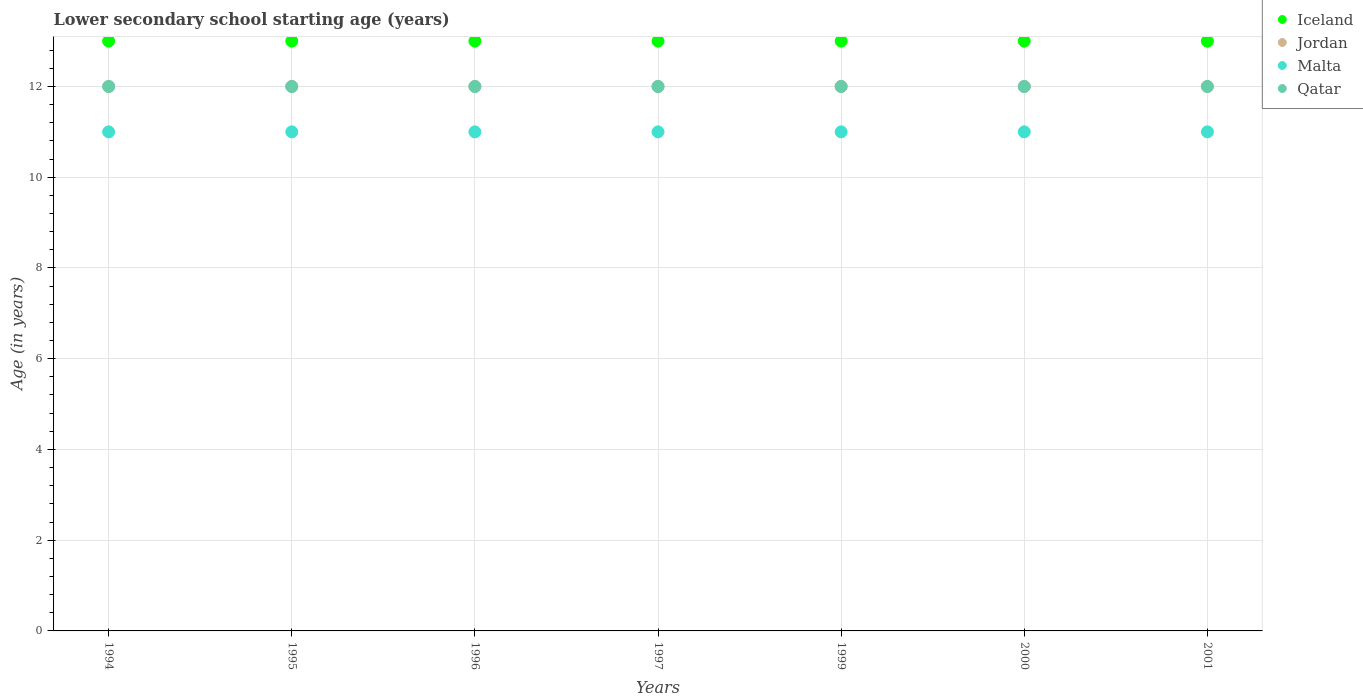How many different coloured dotlines are there?
Offer a very short reply. 4. Across all years, what is the minimum lower secondary school starting age of children in Malta?
Keep it short and to the point. 11. In which year was the lower secondary school starting age of children in Iceland maximum?
Ensure brevity in your answer.  1994. What is the total lower secondary school starting age of children in Iceland in the graph?
Make the answer very short. 91. What is the difference between the lower secondary school starting age of children in Malta in 1994 and that in 1997?
Ensure brevity in your answer.  0. What is the difference between the lower secondary school starting age of children in Malta in 2001 and the lower secondary school starting age of children in Iceland in 1996?
Offer a very short reply. -2. What is the average lower secondary school starting age of children in Malta per year?
Offer a terse response. 11. What is the ratio of the lower secondary school starting age of children in Iceland in 1994 to that in 1995?
Ensure brevity in your answer.  1. Is the difference between the lower secondary school starting age of children in Iceland in 1995 and 2001 greater than the difference between the lower secondary school starting age of children in Jordan in 1995 and 2001?
Keep it short and to the point. No. In how many years, is the lower secondary school starting age of children in Jordan greater than the average lower secondary school starting age of children in Jordan taken over all years?
Provide a short and direct response. 0. Is it the case that in every year, the sum of the lower secondary school starting age of children in Malta and lower secondary school starting age of children in Jordan  is greater than the sum of lower secondary school starting age of children in Iceland and lower secondary school starting age of children in Qatar?
Ensure brevity in your answer.  No. Does the lower secondary school starting age of children in Iceland monotonically increase over the years?
Offer a terse response. No. How many years are there in the graph?
Your response must be concise. 7. What is the difference between two consecutive major ticks on the Y-axis?
Provide a short and direct response. 2. Does the graph contain any zero values?
Keep it short and to the point. No. Does the graph contain grids?
Ensure brevity in your answer.  Yes. Where does the legend appear in the graph?
Your response must be concise. Top right. How many legend labels are there?
Ensure brevity in your answer.  4. How are the legend labels stacked?
Offer a terse response. Vertical. What is the title of the graph?
Your answer should be very brief. Lower secondary school starting age (years). What is the label or title of the X-axis?
Provide a succinct answer. Years. What is the label or title of the Y-axis?
Your response must be concise. Age (in years). What is the Age (in years) of Iceland in 1994?
Your answer should be compact. 13. What is the Age (in years) of Jordan in 1994?
Offer a very short reply. 12. What is the Age (in years) of Malta in 1994?
Give a very brief answer. 11. What is the Age (in years) in Qatar in 1994?
Provide a succinct answer. 12. What is the Age (in years) of Malta in 1995?
Make the answer very short. 11. What is the Age (in years) of Qatar in 1995?
Provide a succinct answer. 12. What is the Age (in years) of Iceland in 1996?
Offer a very short reply. 13. What is the Age (in years) of Malta in 1996?
Give a very brief answer. 11. What is the Age (in years) of Qatar in 1996?
Give a very brief answer. 12. What is the Age (in years) in Jordan in 1997?
Provide a succinct answer. 12. What is the Age (in years) of Malta in 1999?
Give a very brief answer. 11. What is the Age (in years) of Qatar in 1999?
Give a very brief answer. 12. What is the Age (in years) of Jordan in 2000?
Keep it short and to the point. 12. What is the Age (in years) of Malta in 2000?
Make the answer very short. 11. What is the Age (in years) in Qatar in 2000?
Offer a terse response. 12. What is the Age (in years) in Iceland in 2001?
Your answer should be compact. 13. What is the Age (in years) of Jordan in 2001?
Your response must be concise. 12. What is the Age (in years) in Malta in 2001?
Provide a short and direct response. 11. What is the Age (in years) in Qatar in 2001?
Offer a very short reply. 12. Across all years, what is the maximum Age (in years) in Jordan?
Offer a terse response. 12. Across all years, what is the maximum Age (in years) of Qatar?
Provide a succinct answer. 12. Across all years, what is the minimum Age (in years) in Iceland?
Offer a very short reply. 13. Across all years, what is the minimum Age (in years) in Malta?
Offer a very short reply. 11. What is the total Age (in years) of Iceland in the graph?
Keep it short and to the point. 91. What is the total Age (in years) of Jordan in the graph?
Provide a short and direct response. 84. What is the difference between the Age (in years) in Jordan in 1994 and that in 1995?
Give a very brief answer. 0. What is the difference between the Age (in years) in Malta in 1994 and that in 1995?
Give a very brief answer. 0. What is the difference between the Age (in years) of Jordan in 1994 and that in 1996?
Your answer should be compact. 0. What is the difference between the Age (in years) of Iceland in 1994 and that in 1997?
Offer a terse response. 0. What is the difference between the Age (in years) of Jordan in 1994 and that in 1997?
Give a very brief answer. 0. What is the difference between the Age (in years) in Malta in 1994 and that in 1997?
Make the answer very short. 0. What is the difference between the Age (in years) of Qatar in 1994 and that in 1997?
Keep it short and to the point. 0. What is the difference between the Age (in years) of Jordan in 1994 and that in 1999?
Ensure brevity in your answer.  0. What is the difference between the Age (in years) of Malta in 1994 and that in 1999?
Your answer should be compact. 0. What is the difference between the Age (in years) of Qatar in 1994 and that in 1999?
Give a very brief answer. 0. What is the difference between the Age (in years) of Iceland in 1994 and that in 2000?
Ensure brevity in your answer.  0. What is the difference between the Age (in years) in Jordan in 1994 and that in 2000?
Offer a very short reply. 0. What is the difference between the Age (in years) of Malta in 1994 and that in 2000?
Your answer should be compact. 0. What is the difference between the Age (in years) in Jordan in 1994 and that in 2001?
Keep it short and to the point. 0. What is the difference between the Age (in years) in Malta in 1994 and that in 2001?
Provide a succinct answer. 0. What is the difference between the Age (in years) of Iceland in 1995 and that in 1996?
Provide a succinct answer. 0. What is the difference between the Age (in years) in Malta in 1995 and that in 1996?
Ensure brevity in your answer.  0. What is the difference between the Age (in years) of Qatar in 1995 and that in 1997?
Provide a short and direct response. 0. What is the difference between the Age (in years) of Iceland in 1995 and that in 1999?
Ensure brevity in your answer.  0. What is the difference between the Age (in years) in Jordan in 1995 and that in 1999?
Ensure brevity in your answer.  0. What is the difference between the Age (in years) in Qatar in 1995 and that in 1999?
Your answer should be very brief. 0. What is the difference between the Age (in years) in Jordan in 1995 and that in 2001?
Offer a terse response. 0. What is the difference between the Age (in years) in Qatar in 1995 and that in 2001?
Provide a succinct answer. 0. What is the difference between the Age (in years) in Iceland in 1996 and that in 1997?
Your answer should be compact. 0. What is the difference between the Age (in years) of Qatar in 1996 and that in 1997?
Keep it short and to the point. 0. What is the difference between the Age (in years) of Iceland in 1996 and that in 1999?
Your answer should be very brief. 0. What is the difference between the Age (in years) of Jordan in 1996 and that in 1999?
Ensure brevity in your answer.  0. What is the difference between the Age (in years) of Malta in 1996 and that in 1999?
Offer a very short reply. 0. What is the difference between the Age (in years) of Iceland in 1996 and that in 2001?
Make the answer very short. 0. What is the difference between the Age (in years) in Jordan in 1997 and that in 1999?
Provide a short and direct response. 0. What is the difference between the Age (in years) of Jordan in 1997 and that in 2000?
Keep it short and to the point. 0. What is the difference between the Age (in years) of Malta in 1997 and that in 2000?
Offer a terse response. 0. What is the difference between the Age (in years) in Iceland in 1997 and that in 2001?
Provide a succinct answer. 0. What is the difference between the Age (in years) of Malta in 1999 and that in 2000?
Provide a succinct answer. 0. What is the difference between the Age (in years) of Qatar in 1999 and that in 2000?
Provide a succinct answer. 0. What is the difference between the Age (in years) of Iceland in 1999 and that in 2001?
Offer a terse response. 0. What is the difference between the Age (in years) of Qatar in 2000 and that in 2001?
Make the answer very short. 0. What is the difference between the Age (in years) of Iceland in 1994 and the Age (in years) of Jordan in 1995?
Provide a short and direct response. 1. What is the difference between the Age (in years) of Iceland in 1994 and the Age (in years) of Jordan in 1996?
Your answer should be very brief. 1. What is the difference between the Age (in years) of Iceland in 1994 and the Age (in years) of Qatar in 1996?
Ensure brevity in your answer.  1. What is the difference between the Age (in years) in Jordan in 1994 and the Age (in years) in Malta in 1996?
Provide a succinct answer. 1. What is the difference between the Age (in years) in Jordan in 1994 and the Age (in years) in Qatar in 1996?
Give a very brief answer. 0. What is the difference between the Age (in years) of Malta in 1994 and the Age (in years) of Qatar in 1996?
Ensure brevity in your answer.  -1. What is the difference between the Age (in years) in Iceland in 1994 and the Age (in years) in Jordan in 1997?
Your answer should be very brief. 1. What is the difference between the Age (in years) in Iceland in 1994 and the Age (in years) in Malta in 1997?
Give a very brief answer. 2. What is the difference between the Age (in years) of Jordan in 1994 and the Age (in years) of Malta in 1997?
Your response must be concise. 1. What is the difference between the Age (in years) in Malta in 1994 and the Age (in years) in Qatar in 1997?
Ensure brevity in your answer.  -1. What is the difference between the Age (in years) of Iceland in 1994 and the Age (in years) of Jordan in 1999?
Offer a terse response. 1. What is the difference between the Age (in years) in Iceland in 1994 and the Age (in years) in Malta in 1999?
Your response must be concise. 2. What is the difference between the Age (in years) in Iceland in 1994 and the Age (in years) in Qatar in 1999?
Provide a succinct answer. 1. What is the difference between the Age (in years) in Jordan in 1994 and the Age (in years) in Malta in 1999?
Make the answer very short. 1. What is the difference between the Age (in years) in Malta in 1994 and the Age (in years) in Qatar in 1999?
Make the answer very short. -1. What is the difference between the Age (in years) of Iceland in 1994 and the Age (in years) of Jordan in 2000?
Your response must be concise. 1. What is the difference between the Age (in years) in Iceland in 1994 and the Age (in years) in Malta in 2000?
Provide a succinct answer. 2. What is the difference between the Age (in years) in Iceland in 1994 and the Age (in years) in Qatar in 2000?
Keep it short and to the point. 1. What is the difference between the Age (in years) in Iceland in 1994 and the Age (in years) in Malta in 2001?
Offer a terse response. 2. What is the difference between the Age (in years) in Iceland in 1995 and the Age (in years) in Jordan in 1996?
Provide a succinct answer. 1. What is the difference between the Age (in years) of Iceland in 1995 and the Age (in years) of Malta in 1996?
Give a very brief answer. 2. What is the difference between the Age (in years) in Malta in 1995 and the Age (in years) in Qatar in 1996?
Your answer should be compact. -1. What is the difference between the Age (in years) in Iceland in 1995 and the Age (in years) in Malta in 1997?
Offer a very short reply. 2. What is the difference between the Age (in years) in Jordan in 1995 and the Age (in years) in Malta in 1997?
Your answer should be very brief. 1. What is the difference between the Age (in years) of Malta in 1995 and the Age (in years) of Qatar in 1997?
Offer a very short reply. -1. What is the difference between the Age (in years) in Iceland in 1995 and the Age (in years) in Jordan in 1999?
Your response must be concise. 1. What is the difference between the Age (in years) in Iceland in 1995 and the Age (in years) in Malta in 1999?
Offer a terse response. 2. What is the difference between the Age (in years) of Malta in 1995 and the Age (in years) of Qatar in 1999?
Your answer should be very brief. -1. What is the difference between the Age (in years) in Iceland in 1995 and the Age (in years) in Jordan in 2000?
Make the answer very short. 1. What is the difference between the Age (in years) in Iceland in 1995 and the Age (in years) in Malta in 2000?
Ensure brevity in your answer.  2. What is the difference between the Age (in years) of Iceland in 1995 and the Age (in years) of Qatar in 2000?
Make the answer very short. 1. What is the difference between the Age (in years) of Jordan in 1995 and the Age (in years) of Qatar in 2000?
Ensure brevity in your answer.  0. What is the difference between the Age (in years) of Malta in 1995 and the Age (in years) of Qatar in 2000?
Keep it short and to the point. -1. What is the difference between the Age (in years) in Iceland in 1995 and the Age (in years) in Jordan in 2001?
Your answer should be compact. 1. What is the difference between the Age (in years) in Jordan in 1995 and the Age (in years) in Malta in 2001?
Make the answer very short. 1. What is the difference between the Age (in years) in Jordan in 1995 and the Age (in years) in Qatar in 2001?
Keep it short and to the point. 0. What is the difference between the Age (in years) in Iceland in 1996 and the Age (in years) in Jordan in 1997?
Your answer should be very brief. 1. What is the difference between the Age (in years) in Iceland in 1996 and the Age (in years) in Malta in 1997?
Offer a very short reply. 2. What is the difference between the Age (in years) in Iceland in 1996 and the Age (in years) in Qatar in 1997?
Give a very brief answer. 1. What is the difference between the Age (in years) in Jordan in 1996 and the Age (in years) in Qatar in 1997?
Your response must be concise. 0. What is the difference between the Age (in years) of Iceland in 1996 and the Age (in years) of Jordan in 1999?
Your answer should be compact. 1. What is the difference between the Age (in years) in Iceland in 1996 and the Age (in years) in Malta in 1999?
Provide a succinct answer. 2. What is the difference between the Age (in years) in Jordan in 1996 and the Age (in years) in Qatar in 1999?
Keep it short and to the point. 0. What is the difference between the Age (in years) in Iceland in 1996 and the Age (in years) in Malta in 2000?
Make the answer very short. 2. What is the difference between the Age (in years) of Iceland in 1996 and the Age (in years) of Jordan in 2001?
Provide a short and direct response. 1. What is the difference between the Age (in years) in Iceland in 1996 and the Age (in years) in Qatar in 2001?
Give a very brief answer. 1. What is the difference between the Age (in years) of Jordan in 1996 and the Age (in years) of Malta in 2001?
Make the answer very short. 1. What is the difference between the Age (in years) in Jordan in 1996 and the Age (in years) in Qatar in 2001?
Make the answer very short. 0. What is the difference between the Age (in years) in Iceland in 1997 and the Age (in years) in Jordan in 1999?
Offer a very short reply. 1. What is the difference between the Age (in years) in Iceland in 1997 and the Age (in years) in Malta in 1999?
Keep it short and to the point. 2. What is the difference between the Age (in years) of Iceland in 1997 and the Age (in years) of Qatar in 1999?
Ensure brevity in your answer.  1. What is the difference between the Age (in years) in Jordan in 1997 and the Age (in years) in Qatar in 1999?
Provide a short and direct response. 0. What is the difference between the Age (in years) of Jordan in 1997 and the Age (in years) of Qatar in 2000?
Provide a short and direct response. 0. What is the difference between the Age (in years) of Iceland in 1997 and the Age (in years) of Jordan in 2001?
Provide a succinct answer. 1. What is the difference between the Age (in years) of Iceland in 1997 and the Age (in years) of Qatar in 2001?
Offer a terse response. 1. What is the difference between the Age (in years) of Jordan in 1997 and the Age (in years) of Malta in 2001?
Your answer should be very brief. 1. What is the difference between the Age (in years) in Malta in 1997 and the Age (in years) in Qatar in 2001?
Your answer should be very brief. -1. What is the difference between the Age (in years) of Iceland in 1999 and the Age (in years) of Malta in 2000?
Your response must be concise. 2. What is the difference between the Age (in years) of Iceland in 1999 and the Age (in years) of Qatar in 2000?
Keep it short and to the point. 1. What is the difference between the Age (in years) in Jordan in 1999 and the Age (in years) in Malta in 2000?
Ensure brevity in your answer.  1. What is the difference between the Age (in years) of Malta in 1999 and the Age (in years) of Qatar in 2000?
Provide a succinct answer. -1. What is the difference between the Age (in years) in Iceland in 1999 and the Age (in years) in Jordan in 2001?
Ensure brevity in your answer.  1. What is the difference between the Age (in years) in Iceland in 1999 and the Age (in years) in Qatar in 2001?
Make the answer very short. 1. What is the difference between the Age (in years) of Jordan in 1999 and the Age (in years) of Qatar in 2001?
Your answer should be compact. 0. What is the difference between the Age (in years) in Malta in 1999 and the Age (in years) in Qatar in 2001?
Ensure brevity in your answer.  -1. What is the difference between the Age (in years) in Iceland in 2000 and the Age (in years) in Jordan in 2001?
Offer a very short reply. 1. What is the difference between the Age (in years) of Iceland in 2000 and the Age (in years) of Malta in 2001?
Give a very brief answer. 2. What is the difference between the Age (in years) in Iceland in 2000 and the Age (in years) in Qatar in 2001?
Provide a succinct answer. 1. What is the difference between the Age (in years) in Jordan in 2000 and the Age (in years) in Malta in 2001?
Your response must be concise. 1. What is the difference between the Age (in years) of Jordan in 2000 and the Age (in years) of Qatar in 2001?
Give a very brief answer. 0. What is the difference between the Age (in years) of Malta in 2000 and the Age (in years) of Qatar in 2001?
Provide a succinct answer. -1. What is the average Age (in years) of Iceland per year?
Your answer should be compact. 13. What is the average Age (in years) of Malta per year?
Provide a short and direct response. 11. In the year 1994, what is the difference between the Age (in years) in Iceland and Age (in years) in Jordan?
Provide a short and direct response. 1. In the year 1994, what is the difference between the Age (in years) of Iceland and Age (in years) of Malta?
Offer a very short reply. 2. In the year 1994, what is the difference between the Age (in years) of Iceland and Age (in years) of Qatar?
Provide a short and direct response. 1. In the year 1994, what is the difference between the Age (in years) in Jordan and Age (in years) in Malta?
Ensure brevity in your answer.  1. In the year 1994, what is the difference between the Age (in years) of Jordan and Age (in years) of Qatar?
Make the answer very short. 0. In the year 1995, what is the difference between the Age (in years) of Iceland and Age (in years) of Jordan?
Keep it short and to the point. 1. In the year 1996, what is the difference between the Age (in years) of Iceland and Age (in years) of Qatar?
Offer a very short reply. 1. In the year 1996, what is the difference between the Age (in years) in Jordan and Age (in years) in Malta?
Keep it short and to the point. 1. In the year 1996, what is the difference between the Age (in years) of Malta and Age (in years) of Qatar?
Your answer should be compact. -1. In the year 1997, what is the difference between the Age (in years) in Iceland and Age (in years) in Jordan?
Provide a short and direct response. 1. In the year 1997, what is the difference between the Age (in years) in Iceland and Age (in years) in Qatar?
Give a very brief answer. 1. In the year 1997, what is the difference between the Age (in years) in Jordan and Age (in years) in Malta?
Give a very brief answer. 1. In the year 1999, what is the difference between the Age (in years) of Iceland and Age (in years) of Malta?
Ensure brevity in your answer.  2. In the year 1999, what is the difference between the Age (in years) of Iceland and Age (in years) of Qatar?
Ensure brevity in your answer.  1. In the year 1999, what is the difference between the Age (in years) of Jordan and Age (in years) of Malta?
Provide a short and direct response. 1. In the year 1999, what is the difference between the Age (in years) in Malta and Age (in years) in Qatar?
Ensure brevity in your answer.  -1. In the year 2000, what is the difference between the Age (in years) in Iceland and Age (in years) in Malta?
Offer a very short reply. 2. In the year 2001, what is the difference between the Age (in years) in Iceland and Age (in years) in Malta?
Make the answer very short. 2. In the year 2001, what is the difference between the Age (in years) of Iceland and Age (in years) of Qatar?
Offer a very short reply. 1. In the year 2001, what is the difference between the Age (in years) of Jordan and Age (in years) of Malta?
Make the answer very short. 1. In the year 2001, what is the difference between the Age (in years) of Jordan and Age (in years) of Qatar?
Your answer should be very brief. 0. In the year 2001, what is the difference between the Age (in years) of Malta and Age (in years) of Qatar?
Give a very brief answer. -1. What is the ratio of the Age (in years) of Iceland in 1994 to that in 1995?
Make the answer very short. 1. What is the ratio of the Age (in years) of Jordan in 1994 to that in 1995?
Your response must be concise. 1. What is the ratio of the Age (in years) in Qatar in 1994 to that in 1995?
Offer a terse response. 1. What is the ratio of the Age (in years) of Iceland in 1994 to that in 1996?
Keep it short and to the point. 1. What is the ratio of the Age (in years) in Malta in 1994 to that in 1996?
Keep it short and to the point. 1. What is the ratio of the Age (in years) of Iceland in 1994 to that in 1997?
Ensure brevity in your answer.  1. What is the ratio of the Age (in years) in Jordan in 1994 to that in 1997?
Keep it short and to the point. 1. What is the ratio of the Age (in years) of Malta in 1994 to that in 1997?
Make the answer very short. 1. What is the ratio of the Age (in years) of Qatar in 1994 to that in 1997?
Ensure brevity in your answer.  1. What is the ratio of the Age (in years) of Jordan in 1994 to that in 1999?
Provide a succinct answer. 1. What is the ratio of the Age (in years) in Malta in 1994 to that in 2000?
Provide a succinct answer. 1. What is the ratio of the Age (in years) of Qatar in 1994 to that in 2000?
Offer a terse response. 1. What is the ratio of the Age (in years) in Malta in 1994 to that in 2001?
Keep it short and to the point. 1. What is the ratio of the Age (in years) in Iceland in 1995 to that in 1996?
Offer a terse response. 1. What is the ratio of the Age (in years) in Jordan in 1995 to that in 1996?
Your response must be concise. 1. What is the ratio of the Age (in years) of Jordan in 1995 to that in 1997?
Provide a succinct answer. 1. What is the ratio of the Age (in years) in Malta in 1995 to that in 1997?
Ensure brevity in your answer.  1. What is the ratio of the Age (in years) of Qatar in 1995 to that in 1997?
Make the answer very short. 1. What is the ratio of the Age (in years) in Malta in 1995 to that in 1999?
Your answer should be compact. 1. What is the ratio of the Age (in years) of Qatar in 1995 to that in 1999?
Give a very brief answer. 1. What is the ratio of the Age (in years) of Iceland in 1995 to that in 2000?
Offer a terse response. 1. What is the ratio of the Age (in years) in Qatar in 1995 to that in 2000?
Keep it short and to the point. 1. What is the ratio of the Age (in years) of Iceland in 1995 to that in 2001?
Offer a terse response. 1. What is the ratio of the Age (in years) in Malta in 1995 to that in 2001?
Give a very brief answer. 1. What is the ratio of the Age (in years) in Qatar in 1995 to that in 2001?
Make the answer very short. 1. What is the ratio of the Age (in years) in Iceland in 1996 to that in 1997?
Provide a short and direct response. 1. What is the ratio of the Age (in years) in Jordan in 1996 to that in 1997?
Provide a succinct answer. 1. What is the ratio of the Age (in years) in Malta in 1996 to that in 1997?
Your response must be concise. 1. What is the ratio of the Age (in years) of Iceland in 1996 to that in 1999?
Your answer should be compact. 1. What is the ratio of the Age (in years) of Malta in 1996 to that in 1999?
Give a very brief answer. 1. What is the ratio of the Age (in years) in Jordan in 1996 to that in 2000?
Your answer should be very brief. 1. What is the ratio of the Age (in years) in Malta in 1996 to that in 2000?
Provide a short and direct response. 1. What is the ratio of the Age (in years) in Jordan in 1996 to that in 2001?
Ensure brevity in your answer.  1. What is the ratio of the Age (in years) in Iceland in 1997 to that in 1999?
Your response must be concise. 1. What is the ratio of the Age (in years) in Qatar in 1997 to that in 2000?
Provide a succinct answer. 1. What is the ratio of the Age (in years) in Jordan in 1997 to that in 2001?
Your answer should be very brief. 1. What is the ratio of the Age (in years) of Malta in 1997 to that in 2001?
Give a very brief answer. 1. What is the ratio of the Age (in years) in Iceland in 1999 to that in 2001?
Provide a short and direct response. 1. What is the ratio of the Age (in years) in Malta in 1999 to that in 2001?
Give a very brief answer. 1. What is the ratio of the Age (in years) of Jordan in 2000 to that in 2001?
Ensure brevity in your answer.  1. What is the ratio of the Age (in years) in Malta in 2000 to that in 2001?
Provide a succinct answer. 1. What is the ratio of the Age (in years) of Qatar in 2000 to that in 2001?
Keep it short and to the point. 1. What is the difference between the highest and the second highest Age (in years) in Iceland?
Provide a succinct answer. 0. What is the difference between the highest and the second highest Age (in years) of Malta?
Provide a short and direct response. 0. What is the difference between the highest and the lowest Age (in years) in Jordan?
Provide a short and direct response. 0. What is the difference between the highest and the lowest Age (in years) of Malta?
Your response must be concise. 0. 